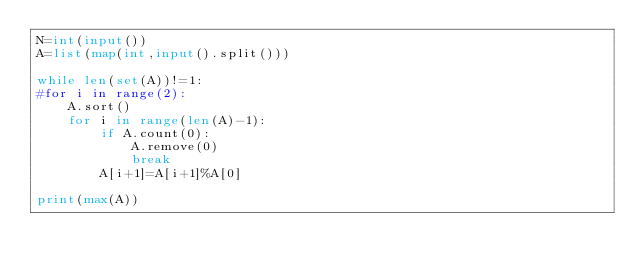<code> <loc_0><loc_0><loc_500><loc_500><_Python_>N=int(input())
A=list(map(int,input().split()))

while len(set(A))!=1:
#for i in range(2):
    A.sort()
    for i in range(len(A)-1):
        if A.count(0):
            A.remove(0)
            break
        A[i+1]=A[i+1]%A[0]

print(max(A))</code> 